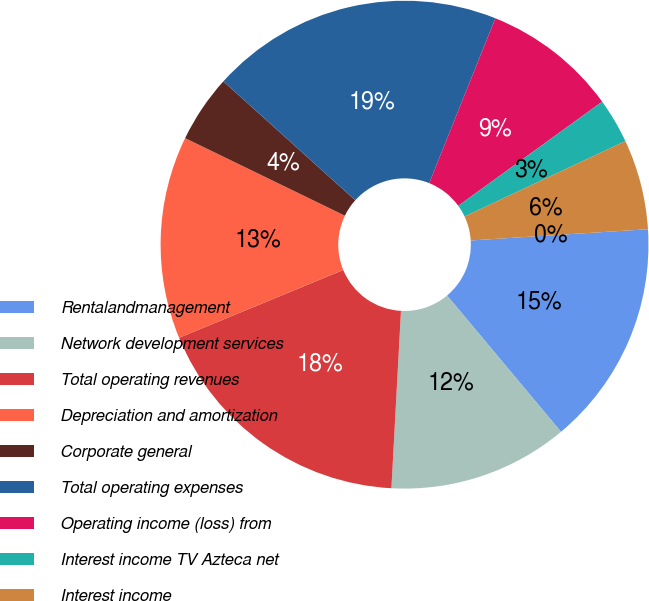<chart> <loc_0><loc_0><loc_500><loc_500><pie_chart><fcel>Rentalandmanagement<fcel>Network development services<fcel>Total operating revenues<fcel>Depreciation and amortization<fcel>Corporate general<fcel>Total operating expenses<fcel>Operating income (loss) from<fcel>Interest income TV Azteca net<fcel>Interest income<fcel>(Loss) income on investments<nl><fcel>14.93%<fcel>11.94%<fcel>17.91%<fcel>13.43%<fcel>4.48%<fcel>19.4%<fcel>8.96%<fcel>2.99%<fcel>5.97%<fcel>0.0%<nl></chart> 